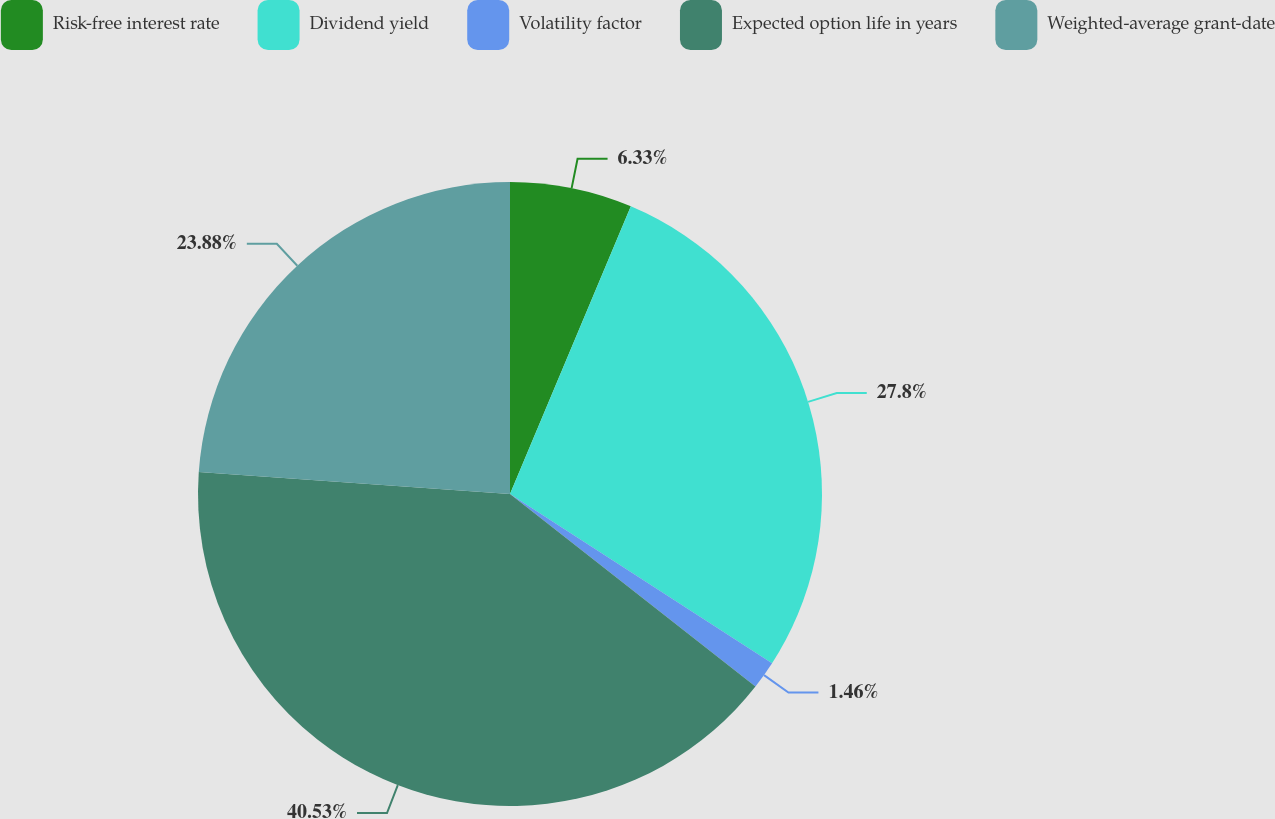<chart> <loc_0><loc_0><loc_500><loc_500><pie_chart><fcel>Risk-free interest rate<fcel>Dividend yield<fcel>Volatility factor<fcel>Expected option life in years<fcel>Weighted-average grant-date<nl><fcel>6.33%<fcel>27.8%<fcel>1.46%<fcel>40.53%<fcel>23.88%<nl></chart> 